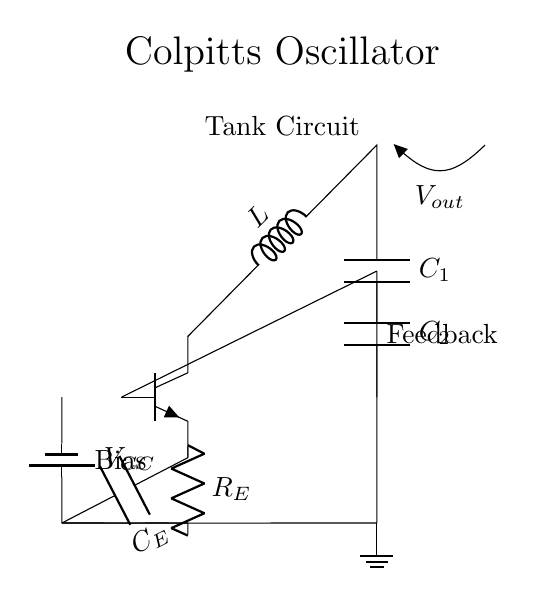What type of oscillator is depicted in the circuit? The circuit shown is a Colpitts oscillator, which is characterized by its use of a combination of inductors and capacitors in the feedback loop to generate oscillations.
Answer: Colpitts oscillator What components are used to form the tank circuit? The tank circuit is formed by an inductor and two capacitors connected in a parallel configuration. This combination is essential for creating the frequency of oscillation in the Colpitts oscillator.
Answer: Inductor and capacitors What is the role of the feedback in this circuit? The feedback in this circuit, indicated by the connection from the capacitor to the base of the transistor, is responsible for sustaining the oscillations by feeding a portion of the output back to the input.
Answer: Sustain oscillations What is the purpose of the emitter resistor in the circuit? The emitter resistor is used to stabilize the operating point of the transistor and ensure consistent performance, particularly in terms of temperature variations and transistor beta fluctuations.
Answer: Stabilize transistor What is the significance of the power supply voltage? The power supply voltage, labeled as VCC, provides the necessary voltage for the transistor to operate in the active region and generate the desired oscillations in the circuit.
Answer: Necessary voltage What effect would increasing the capacitance of C1 have on the oscillation frequency? Increasing the capacitance of C1 would lower the oscillation frequency, as the frequency of the Colpitts oscillator is inversely proportional to the square root of the capacitance and inductance in the tank circuit.
Answer: Lower frequency 